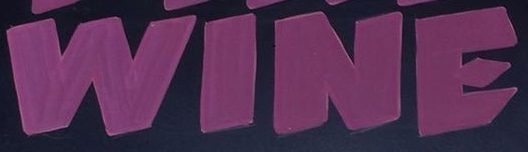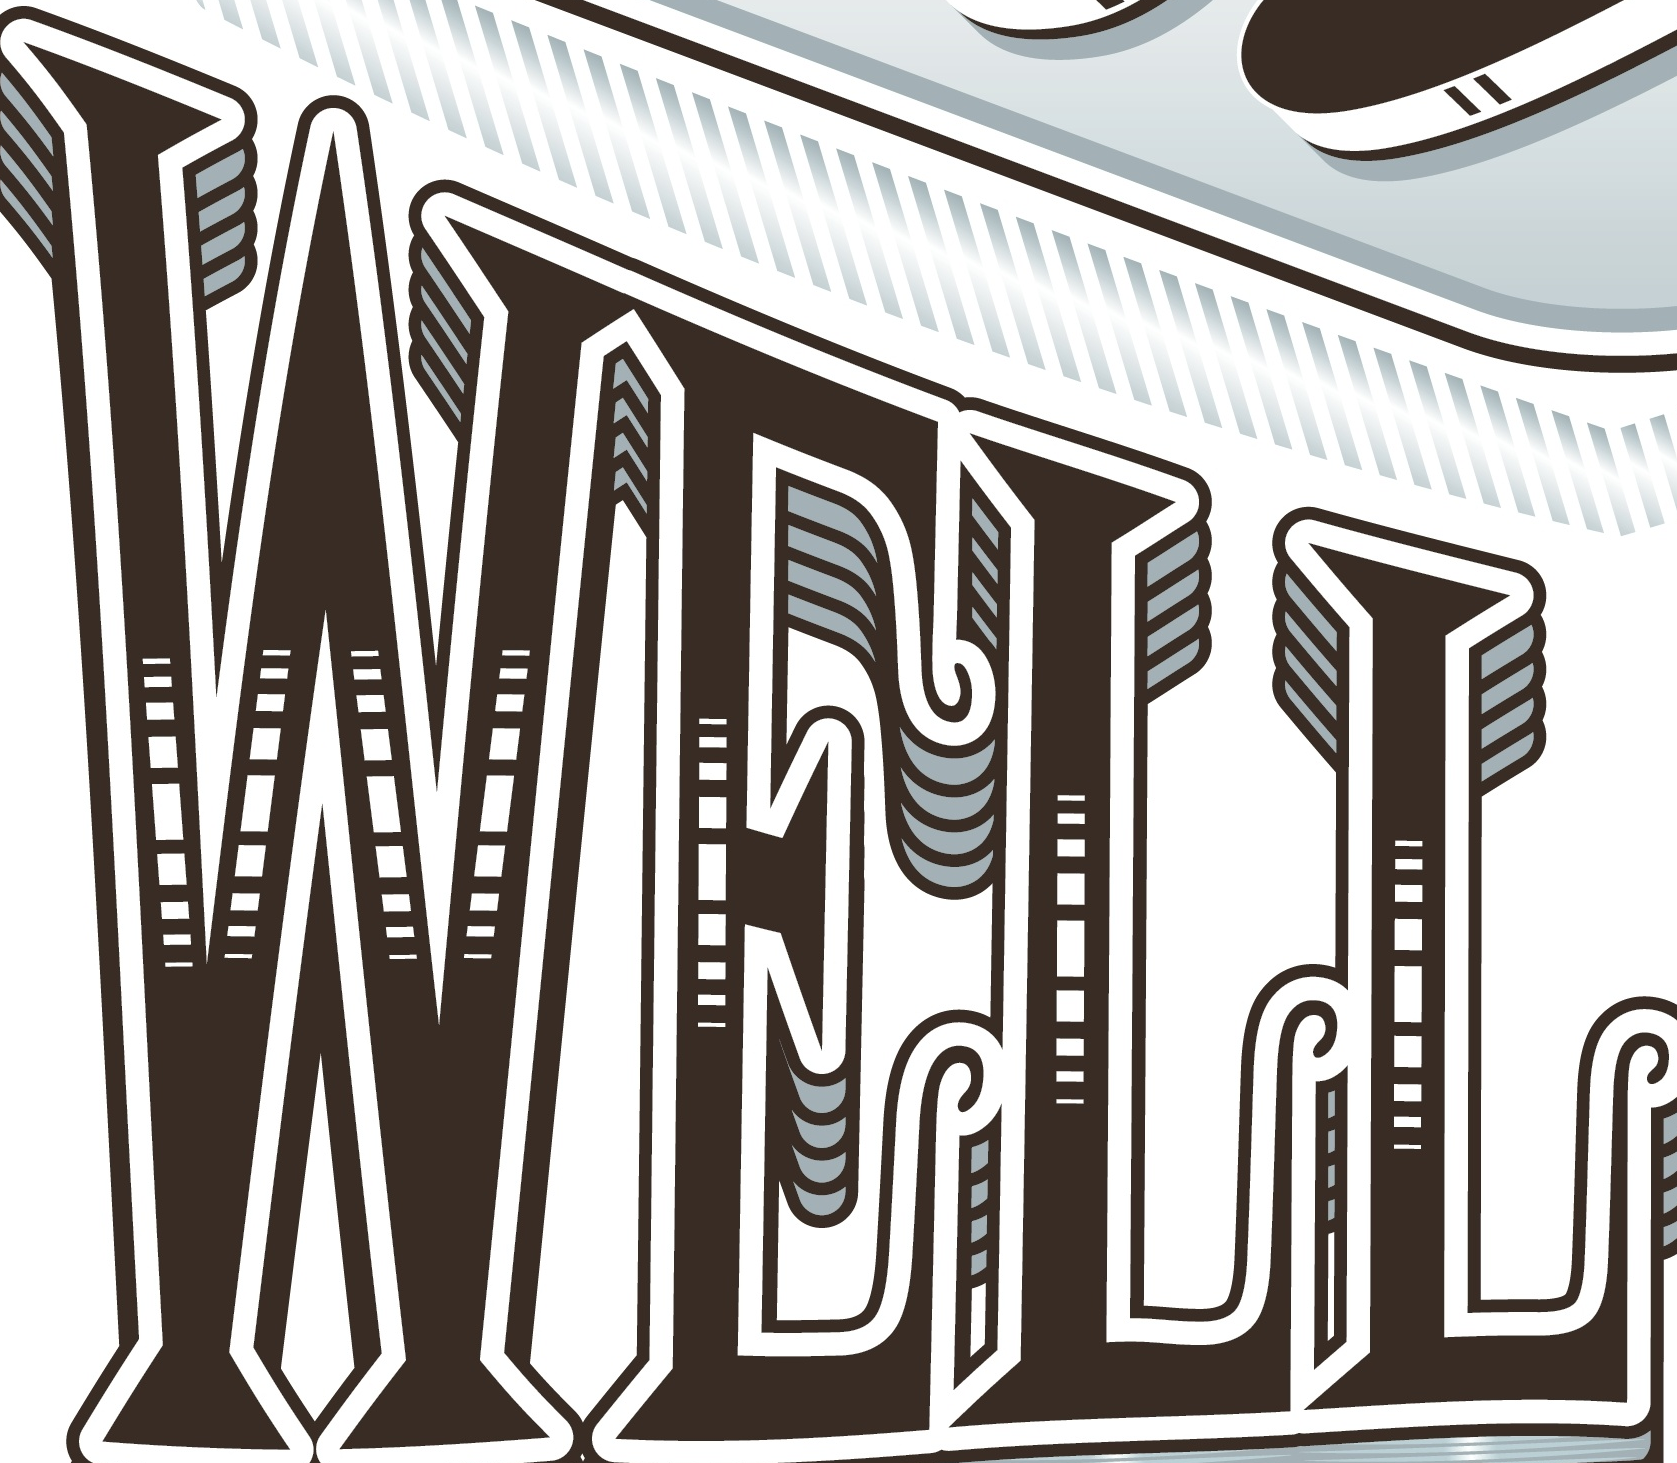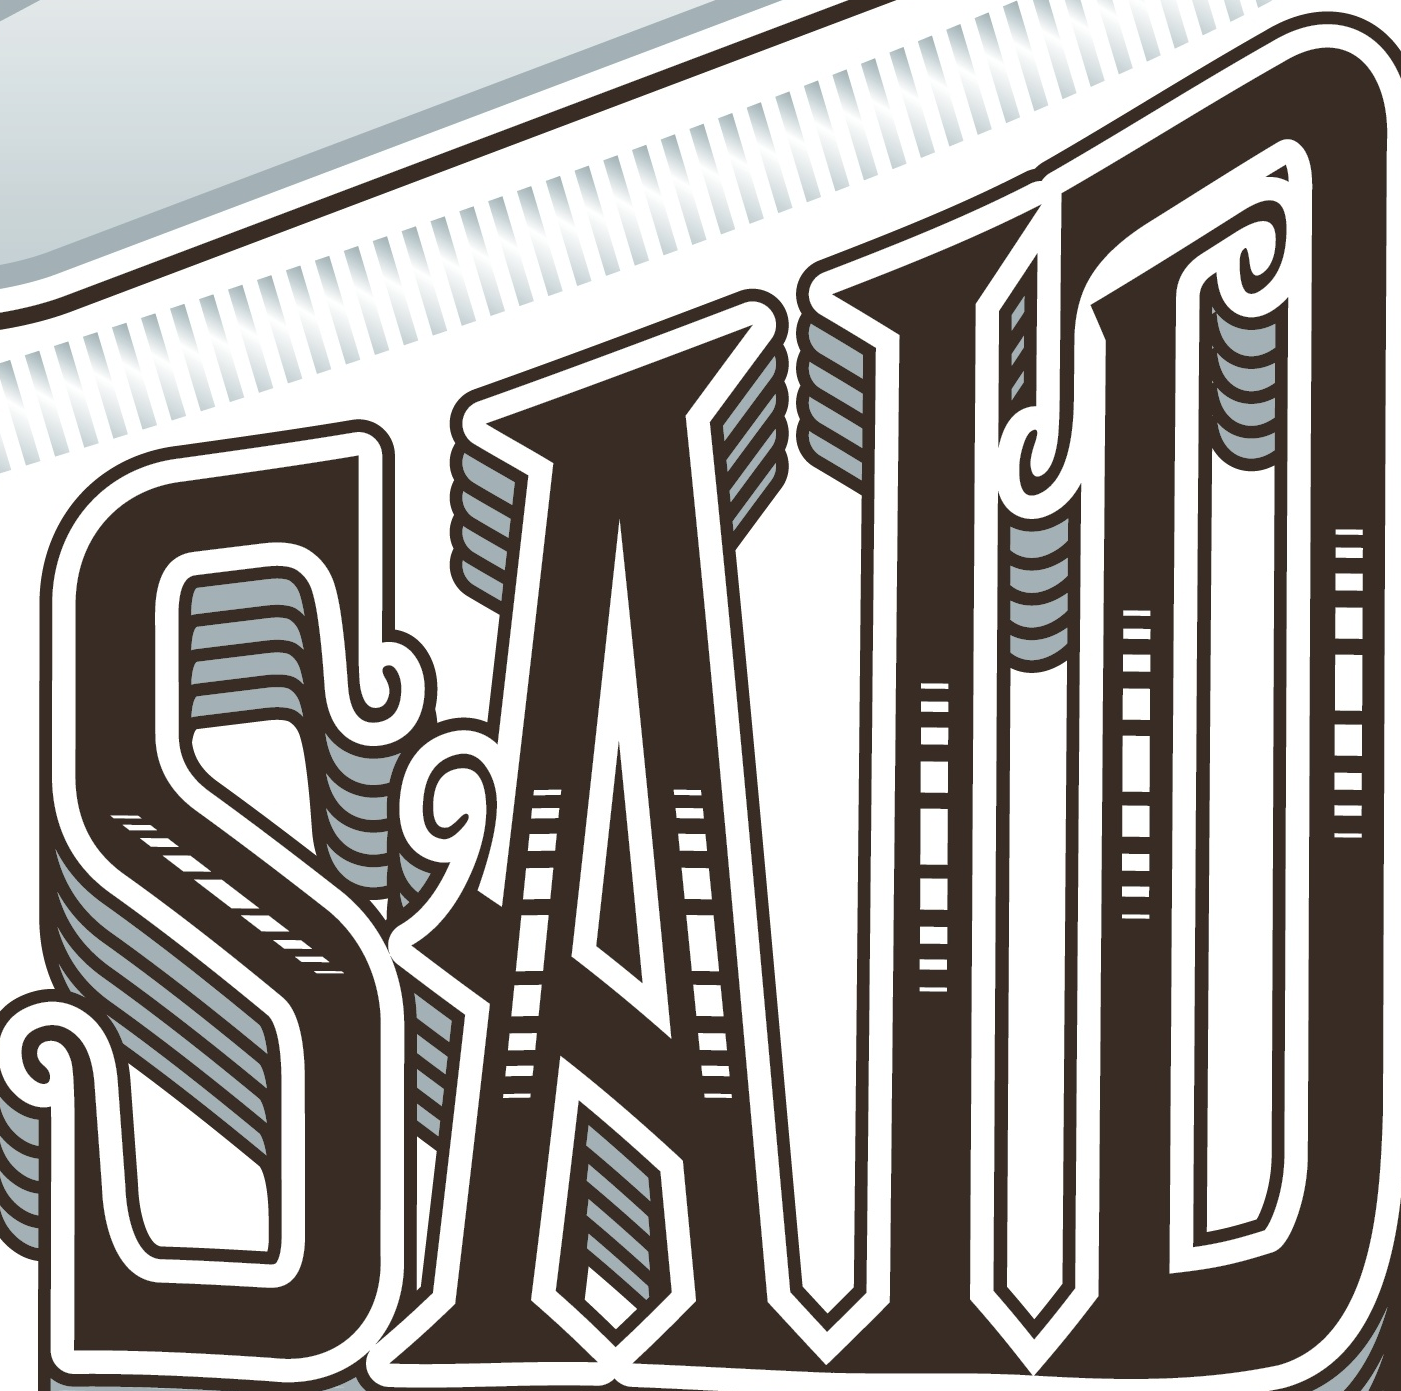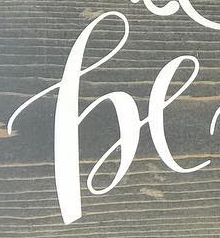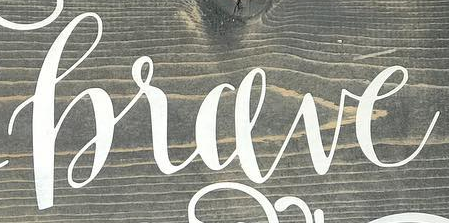Identify the words shown in these images in order, separated by a semicolon. WINE; WELL; SAID; he; hrave 